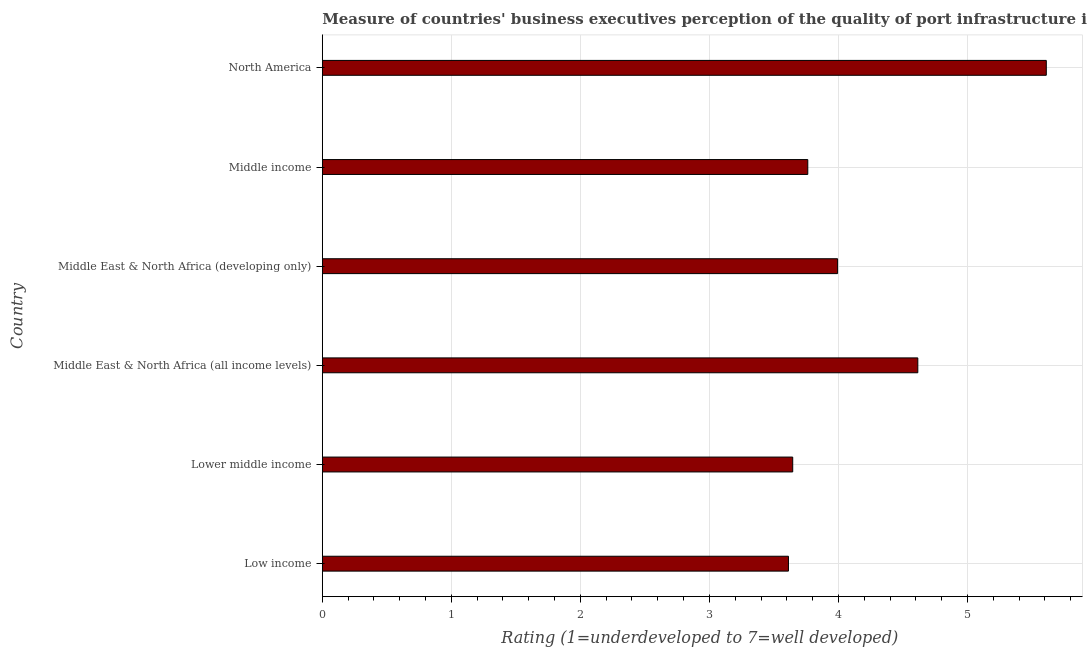What is the title of the graph?
Ensure brevity in your answer.  Measure of countries' business executives perception of the quality of port infrastructure in 2010. What is the label or title of the X-axis?
Keep it short and to the point. Rating (1=underdeveloped to 7=well developed) . What is the label or title of the Y-axis?
Give a very brief answer. Country. What is the rating measuring quality of port infrastructure in North America?
Give a very brief answer. 5.61. Across all countries, what is the maximum rating measuring quality of port infrastructure?
Your response must be concise. 5.61. Across all countries, what is the minimum rating measuring quality of port infrastructure?
Make the answer very short. 3.61. What is the sum of the rating measuring quality of port infrastructure?
Keep it short and to the point. 25.24. What is the difference between the rating measuring quality of port infrastructure in Low income and Middle income?
Your response must be concise. -0.15. What is the average rating measuring quality of port infrastructure per country?
Your answer should be very brief. 4.21. What is the median rating measuring quality of port infrastructure?
Give a very brief answer. 3.88. Is the rating measuring quality of port infrastructure in Lower middle income less than that in Middle income?
Ensure brevity in your answer.  Yes. Is the difference between the rating measuring quality of port infrastructure in Middle East & North Africa (all income levels) and Middle East & North Africa (developing only) greater than the difference between any two countries?
Ensure brevity in your answer.  No. What is the difference between the highest and the second highest rating measuring quality of port infrastructure?
Offer a terse response. 1. Is the sum of the rating measuring quality of port infrastructure in Middle East & North Africa (developing only) and North America greater than the maximum rating measuring quality of port infrastructure across all countries?
Provide a short and direct response. Yes. What is the Rating (1=underdeveloped to 7=well developed)  in Low income?
Ensure brevity in your answer.  3.61. What is the Rating (1=underdeveloped to 7=well developed)  in Lower middle income?
Keep it short and to the point. 3.65. What is the Rating (1=underdeveloped to 7=well developed)  in Middle East & North Africa (all income levels)?
Your answer should be very brief. 4.62. What is the Rating (1=underdeveloped to 7=well developed)  of Middle East & North Africa (developing only)?
Give a very brief answer. 3.99. What is the Rating (1=underdeveloped to 7=well developed)  of Middle income?
Ensure brevity in your answer.  3.76. What is the Rating (1=underdeveloped to 7=well developed)  in North America?
Offer a very short reply. 5.61. What is the difference between the Rating (1=underdeveloped to 7=well developed)  in Low income and Lower middle income?
Provide a succinct answer. -0.03. What is the difference between the Rating (1=underdeveloped to 7=well developed)  in Low income and Middle East & North Africa (all income levels)?
Provide a short and direct response. -1. What is the difference between the Rating (1=underdeveloped to 7=well developed)  in Low income and Middle East & North Africa (developing only)?
Make the answer very short. -0.38. What is the difference between the Rating (1=underdeveloped to 7=well developed)  in Low income and Middle income?
Offer a terse response. -0.15. What is the difference between the Rating (1=underdeveloped to 7=well developed)  in Low income and North America?
Provide a succinct answer. -2. What is the difference between the Rating (1=underdeveloped to 7=well developed)  in Lower middle income and Middle East & North Africa (all income levels)?
Keep it short and to the point. -0.97. What is the difference between the Rating (1=underdeveloped to 7=well developed)  in Lower middle income and Middle East & North Africa (developing only)?
Ensure brevity in your answer.  -0.35. What is the difference between the Rating (1=underdeveloped to 7=well developed)  in Lower middle income and Middle income?
Offer a very short reply. -0.12. What is the difference between the Rating (1=underdeveloped to 7=well developed)  in Lower middle income and North America?
Your response must be concise. -1.97. What is the difference between the Rating (1=underdeveloped to 7=well developed)  in Middle East & North Africa (all income levels) and Middle East & North Africa (developing only)?
Give a very brief answer. 0.62. What is the difference between the Rating (1=underdeveloped to 7=well developed)  in Middle East & North Africa (all income levels) and Middle income?
Your answer should be compact. 0.85. What is the difference between the Rating (1=underdeveloped to 7=well developed)  in Middle East & North Africa (all income levels) and North America?
Your answer should be very brief. -1. What is the difference between the Rating (1=underdeveloped to 7=well developed)  in Middle East & North Africa (developing only) and Middle income?
Make the answer very short. 0.23. What is the difference between the Rating (1=underdeveloped to 7=well developed)  in Middle East & North Africa (developing only) and North America?
Keep it short and to the point. -1.62. What is the difference between the Rating (1=underdeveloped to 7=well developed)  in Middle income and North America?
Give a very brief answer. -1.85. What is the ratio of the Rating (1=underdeveloped to 7=well developed)  in Low income to that in Middle East & North Africa (all income levels)?
Provide a short and direct response. 0.78. What is the ratio of the Rating (1=underdeveloped to 7=well developed)  in Low income to that in Middle East & North Africa (developing only)?
Keep it short and to the point. 0.91. What is the ratio of the Rating (1=underdeveloped to 7=well developed)  in Low income to that in Middle income?
Offer a very short reply. 0.96. What is the ratio of the Rating (1=underdeveloped to 7=well developed)  in Low income to that in North America?
Your answer should be very brief. 0.64. What is the ratio of the Rating (1=underdeveloped to 7=well developed)  in Lower middle income to that in Middle East & North Africa (all income levels)?
Make the answer very short. 0.79. What is the ratio of the Rating (1=underdeveloped to 7=well developed)  in Lower middle income to that in North America?
Offer a very short reply. 0.65. What is the ratio of the Rating (1=underdeveloped to 7=well developed)  in Middle East & North Africa (all income levels) to that in Middle East & North Africa (developing only)?
Provide a short and direct response. 1.16. What is the ratio of the Rating (1=underdeveloped to 7=well developed)  in Middle East & North Africa (all income levels) to that in Middle income?
Your response must be concise. 1.23. What is the ratio of the Rating (1=underdeveloped to 7=well developed)  in Middle East & North Africa (all income levels) to that in North America?
Offer a terse response. 0.82. What is the ratio of the Rating (1=underdeveloped to 7=well developed)  in Middle East & North Africa (developing only) to that in Middle income?
Your answer should be compact. 1.06. What is the ratio of the Rating (1=underdeveloped to 7=well developed)  in Middle East & North Africa (developing only) to that in North America?
Ensure brevity in your answer.  0.71. What is the ratio of the Rating (1=underdeveloped to 7=well developed)  in Middle income to that in North America?
Your answer should be compact. 0.67. 